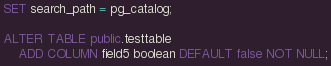Convert code to text. <code><loc_0><loc_0><loc_500><loc_500><_SQL_>SET search_path = pg_catalog;

ALTER TABLE public.testtable
	ADD COLUMN field5 boolean DEFAULT false NOT NULL;</code> 